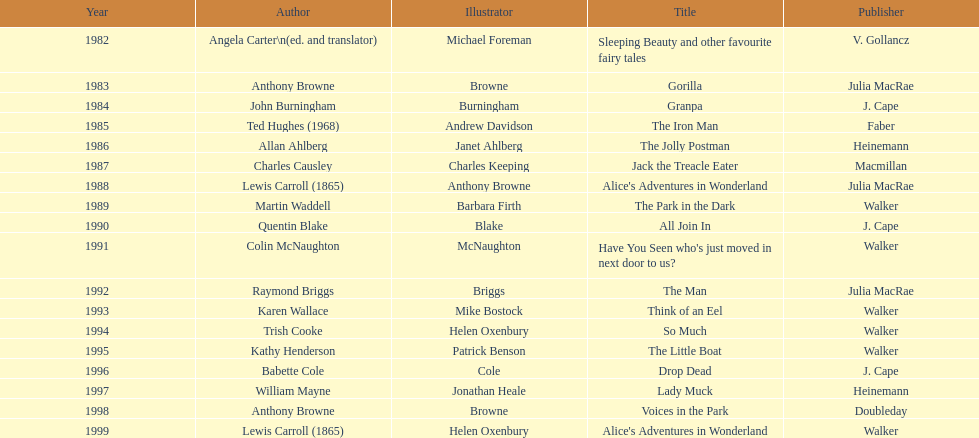For 1999, what is the only title that is listed? Alice's Adventures in Wonderland. 